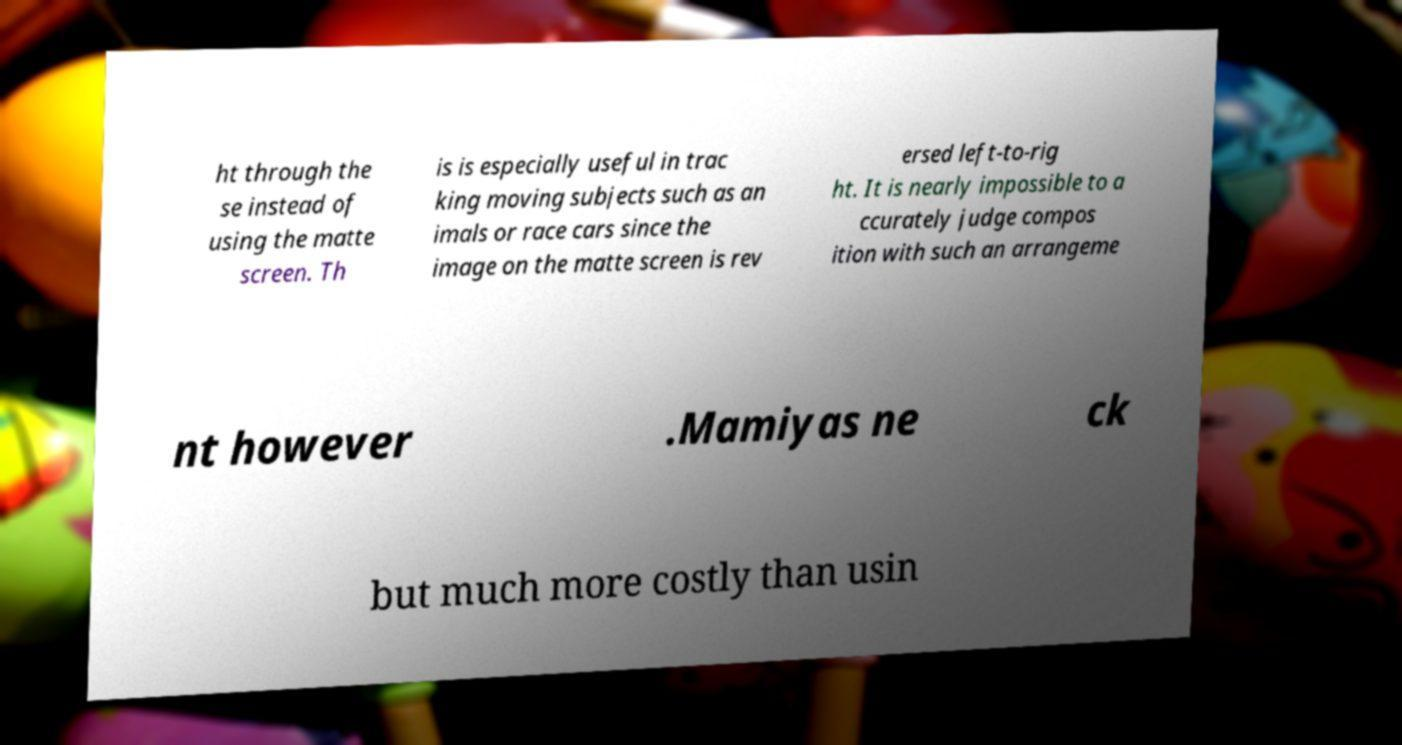Can you read and provide the text displayed in the image?This photo seems to have some interesting text. Can you extract and type it out for me? ht through the se instead of using the matte screen. Th is is especially useful in trac king moving subjects such as an imals or race cars since the image on the matte screen is rev ersed left-to-rig ht. It is nearly impossible to a ccurately judge compos ition with such an arrangeme nt however .Mamiyas ne ck but much more costly than usin 